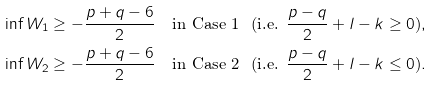<formula> <loc_0><loc_0><loc_500><loc_500>& \inf W _ { 1 } \geq - \frac { p + q - 6 } { 2 } \quad \text {in Case 1 \ (i.e. $\frac{p-q}{2}+l-k\geq0$)} , \\ & \inf W _ { 2 } \geq - \frac { p + q - 6 } { 2 } \quad \text {in Case 2 \ (i.e. $\frac{p-q}{2}+l-k\leq0$)} .</formula> 